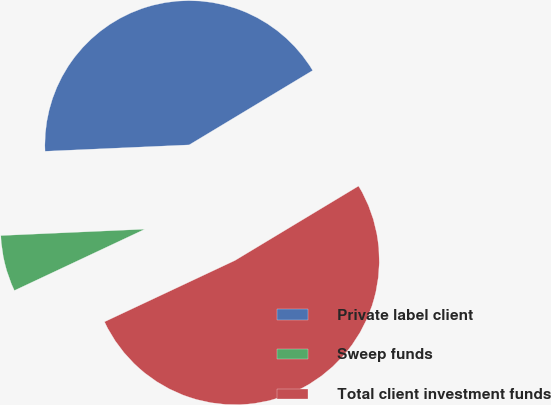<chart> <loc_0><loc_0><loc_500><loc_500><pie_chart><fcel>Private label client<fcel>Sweep funds<fcel>Total client investment funds<nl><fcel>42.07%<fcel>6.29%<fcel>51.63%<nl></chart> 